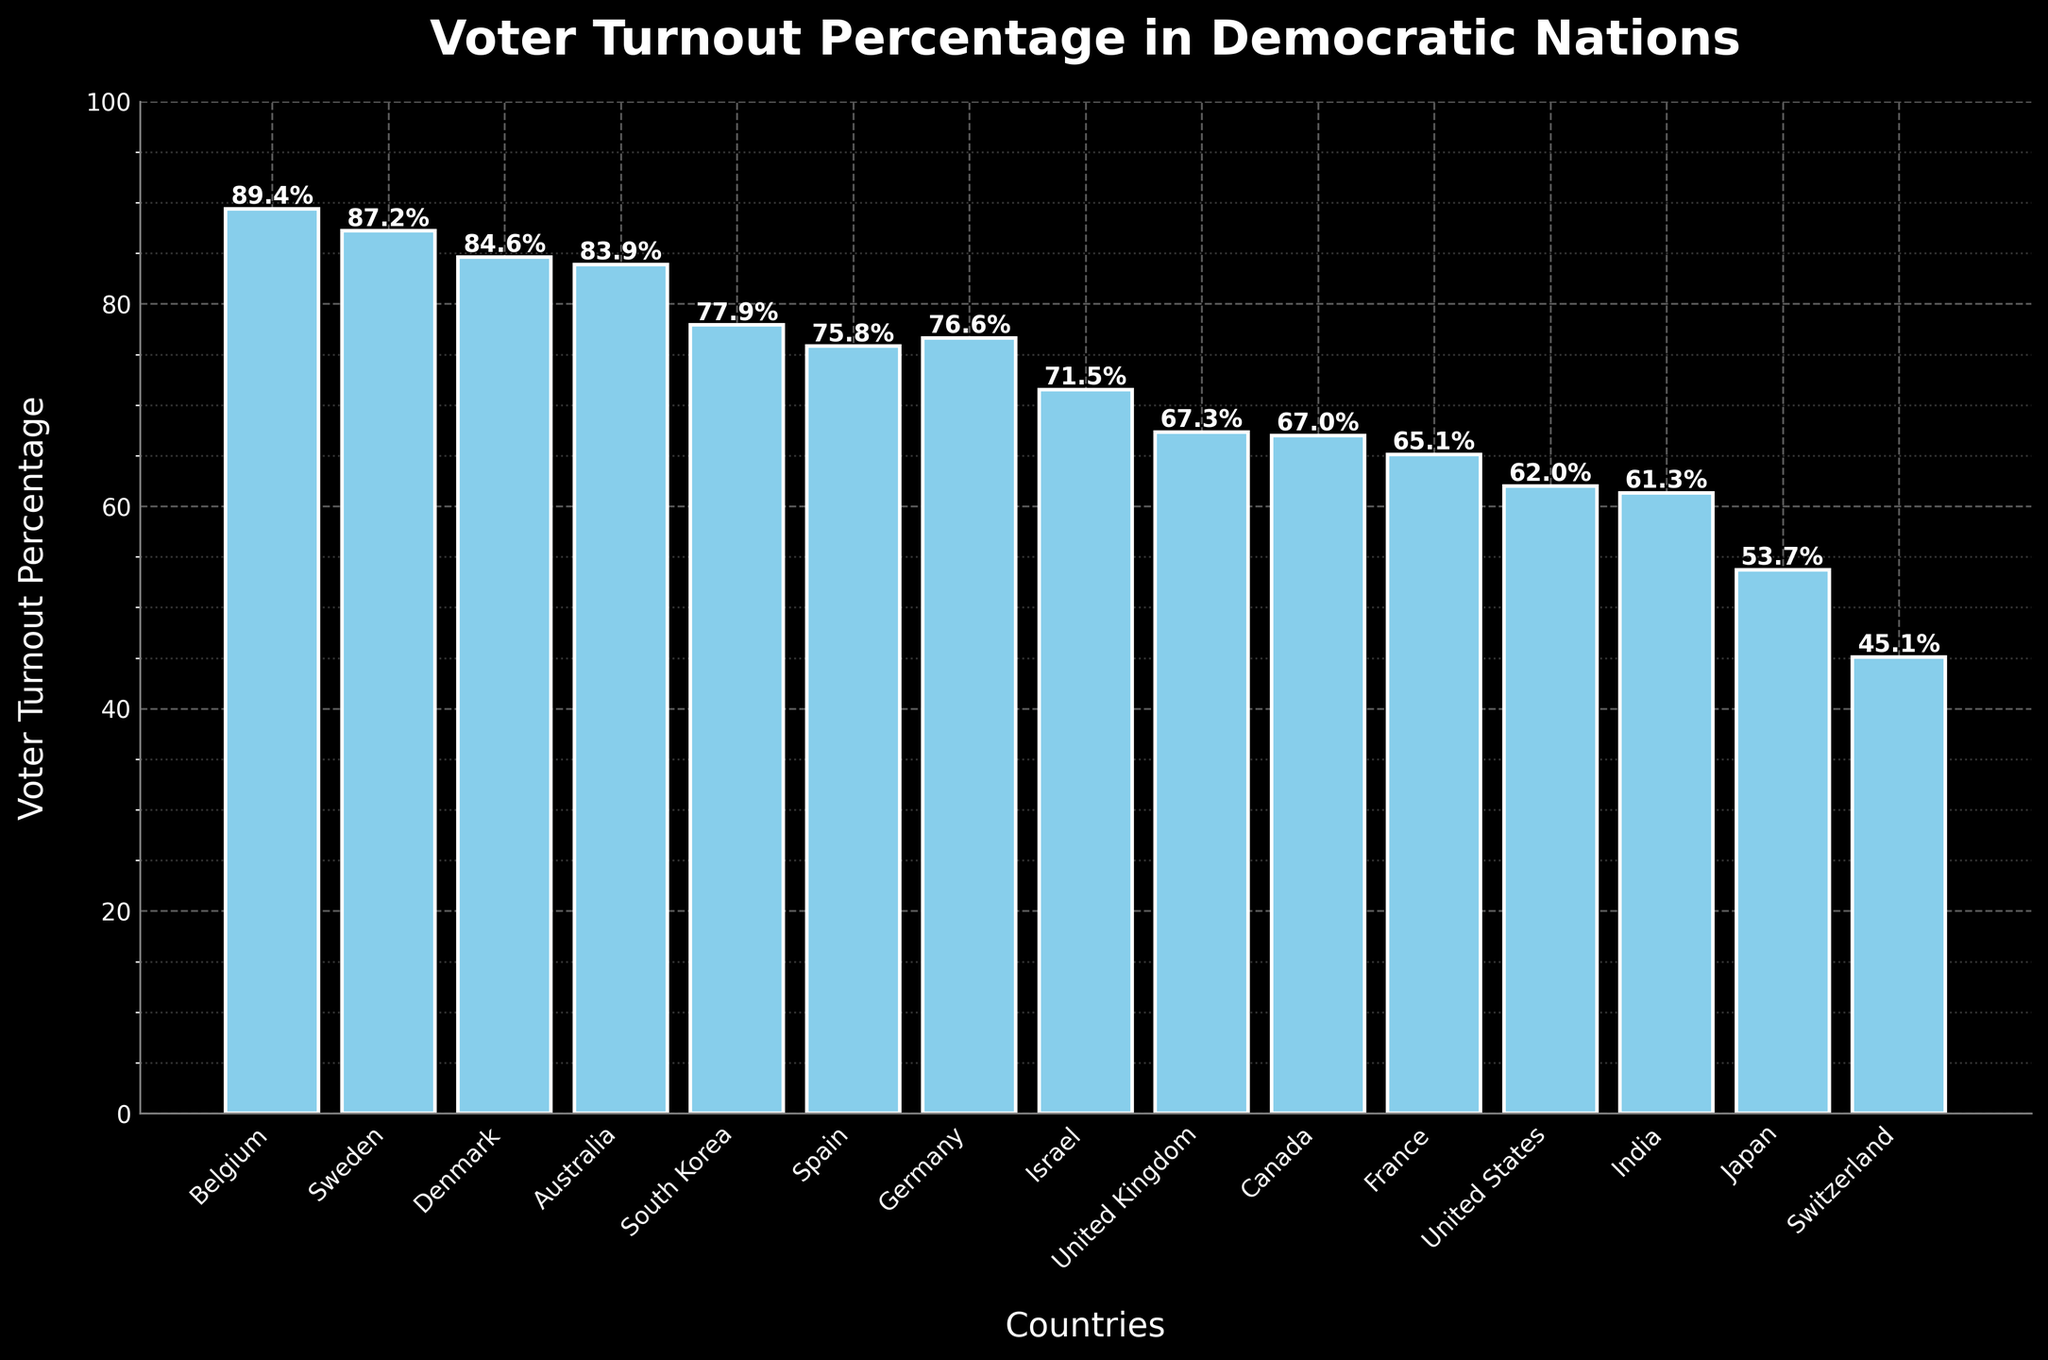What's the voter turnout percentage in Belgium? From the bar representing Belgium, its height reaches the 89.4% mark.
Answer: 89.4% Which two countries have almost similar voter turnout percentages? By observing the heights of the bars, Canada (67.0%) and the United Kingdom (67.3%) have very similar turnout percentages, as their bar heights are almost identical.
Answer: United Kingdom and Canada Which country has the lowest voter turnout percentage? The bar representing Switzerland is the shortest on the chart, indicating the lowest turnout percentage of 45.1%.
Answer: Switzerland How much higher is the voter turnout percentage in South Korea compared to Israel? Subtract the voter turnout percentage of Israel (71.5%) from South Korea (77.9%). 77.9% - 71.5% = 6.4%.
Answer: 6.4% What is the average voter turnout percentage of the top three countries? The top three countries by voter turnout percentage are Belgium (89.4%), Sweden (87.2%), and Denmark (84.6%). The average is (89.4% + 87.2% + 84.6%) / 3 = 87.1%.
Answer: 87.1% Which countries have a voter turnout greater than 80%? Observing the bars, the countries are Belgium (89.4%), Sweden (87.2%), Denmark (84.6%), and Australia (83.9%).
Answer: Belgium, Sweden, Denmark, Australia What is the difference between the voter turnout in Germany and France? Subtract the voter turnout percentage of France (65.1%) from that of Germany (76.6%). 76.6% - 65.1% = 11.5%.
Answer: 11.5% Is the voter turnout percentage in India higher or lower than Japan? The bar for India is higher than that of Japan, indicating India's voter turnout percentage (61.3%) is higher than Japan's (53.7%).
Answer: Higher Which country has a voter turnout close to 75%? Spain has a voter turnout percentage of 75.8%, as observed from its bar.
Answer: Spain 